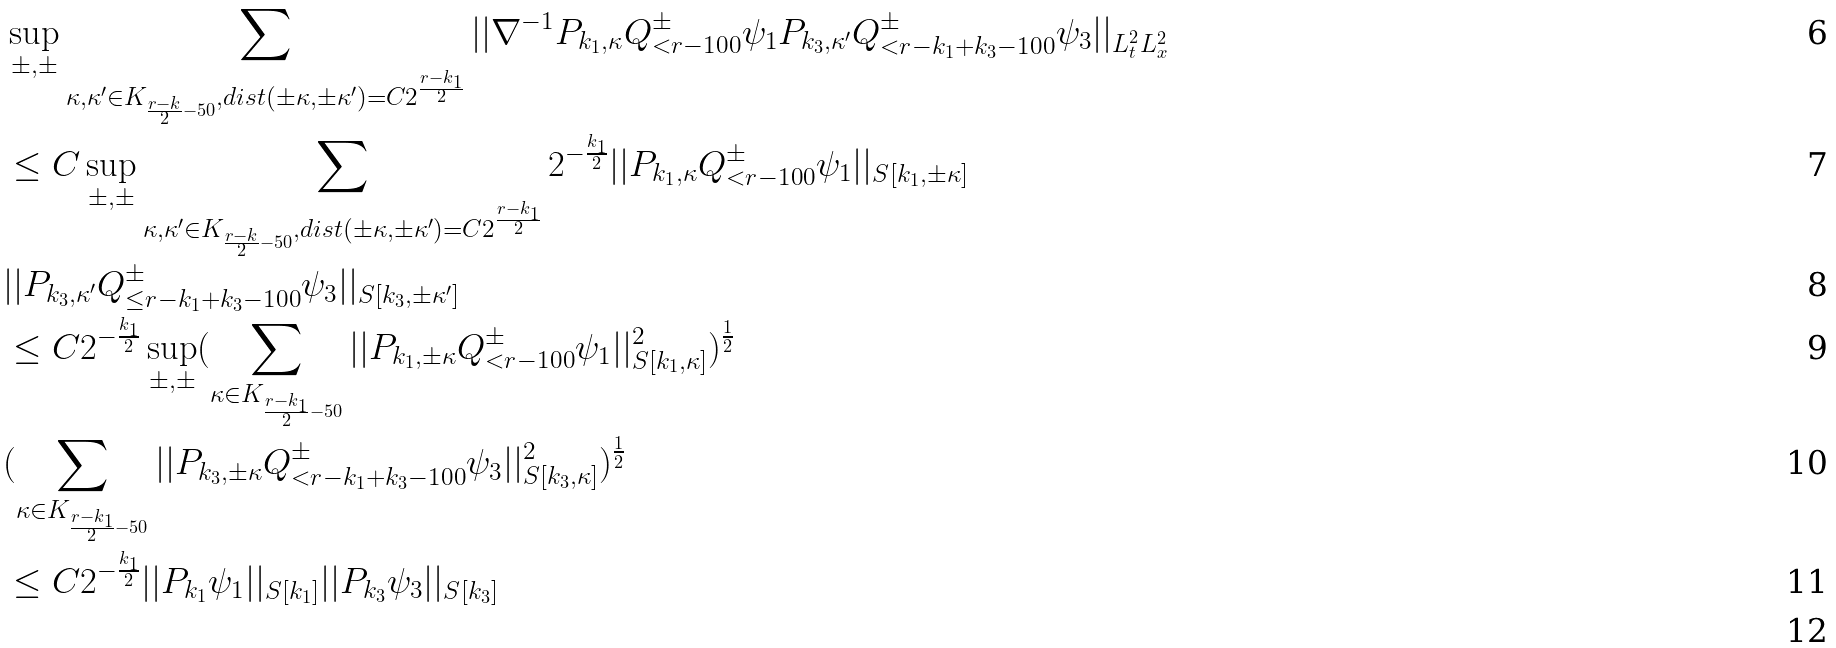<formula> <loc_0><loc_0><loc_500><loc_500>& \sup _ { \pm , \pm } \sum _ { \kappa , \kappa ^ { \prime } \in K _ { \frac { r - k } { 2 } - 5 0 } , d i s t ( \pm \kappa , \pm \kappa ^ { \prime } ) = C 2 ^ { \frac { r - k _ { 1 } } { 2 } } } | | \nabla ^ { - 1 } P _ { k _ { 1 } , \kappa } Q ^ { \pm } _ { < r - 1 0 0 } \psi _ { 1 } P _ { k _ { 3 } , \kappa ^ { \prime } } Q ^ { \pm } _ { < r - k _ { 1 } + k _ { 3 } - 1 0 0 } \psi _ { 3 } | | _ { L _ { t } ^ { 2 } L _ { x } ^ { 2 } } \\ & \leq C \sup _ { \pm , \pm } \sum _ { \kappa , \kappa ^ { \prime } \in K _ { \frac { r - k } { 2 } - 5 0 } , d i s t ( \pm \kappa , \pm \kappa ^ { \prime } ) = C 2 ^ { \frac { r - k _ { 1 } } { 2 } } } 2 ^ { - \frac { k _ { 1 } } { 2 } } | | P _ { k _ { 1 } , \kappa } Q ^ { \pm } _ { < r - 1 0 0 } \psi _ { 1 } | | _ { S [ k _ { 1 } , \pm \kappa ] } \\ & | | P _ { k _ { 3 } , \kappa ^ { \prime } } Q ^ { \pm } _ { \leq r - k _ { 1 } + k _ { 3 } - 1 0 0 } \psi _ { 3 } | | _ { S [ k _ { 3 } , \pm \kappa ^ { \prime } ] } \\ & \leq C 2 ^ { - \frac { k _ { 1 } } { 2 } } \sup _ { \pm , \pm } ( \sum _ { \kappa \in K _ { \frac { r - k _ { 1 } } { 2 } - 5 0 } } | | P _ { k _ { 1 } , \pm \kappa } Q ^ { \pm } _ { < r - 1 0 0 } \psi _ { 1 } | | _ { S [ k _ { 1 } , \kappa ] } ^ { 2 } ) ^ { \frac { 1 } { 2 } } \\ & ( \sum _ { \kappa \in K _ { \frac { r - k _ { 1 } } { 2 } - 5 0 } } | | P _ { k _ { 3 } , \pm \kappa } Q ^ { \pm } _ { < r - k _ { 1 } + k _ { 3 } - 1 0 0 } \psi _ { 3 } | | _ { S [ k _ { 3 } , \kappa ] } ^ { 2 } ) ^ { \frac { 1 } { 2 } } \\ & \leq C 2 ^ { - \frac { k _ { 1 } } { 2 } } | | P _ { k _ { 1 } } \psi _ { 1 } | | _ { S [ k _ { 1 } ] } | | P _ { k _ { 3 } } \psi _ { 3 } | | _ { S [ k _ { 3 } ] } \\</formula> 